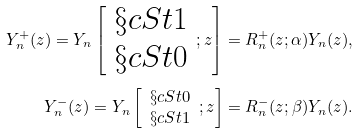Convert formula to latex. <formula><loc_0><loc_0><loc_500><loc_500>Y ^ { + } _ { n } ( z ) = Y _ { n } \left [ \begin{array} { c } \S c S t 1 \\ \S c S t 0 \end{array} ; z \right ] & = R _ { n } ^ { + } ( z ; \alpha ) Y _ { n } ( z ) , \\ Y ^ { - } _ { n } ( z ) = Y _ { n } \left [ \begin{array} { c } \S c S t 0 \\ \S c S t 1 \end{array} ; z \right ] & = R _ { n } ^ { - } ( z ; \beta ) Y _ { n } ( z ) .</formula> 